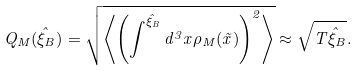<formula> <loc_0><loc_0><loc_500><loc_500>Q _ { M } ( \hat { \xi } _ { B } ) = \sqrt { \left \langle \left ( \int ^ { \hat { \xi } _ { B } } d ^ { 3 } x \rho _ { M } ( \vec { x } ) \right ) ^ { 2 } \right \rangle } \approx \sqrt { T \hat { \xi } _ { B } } .</formula> 